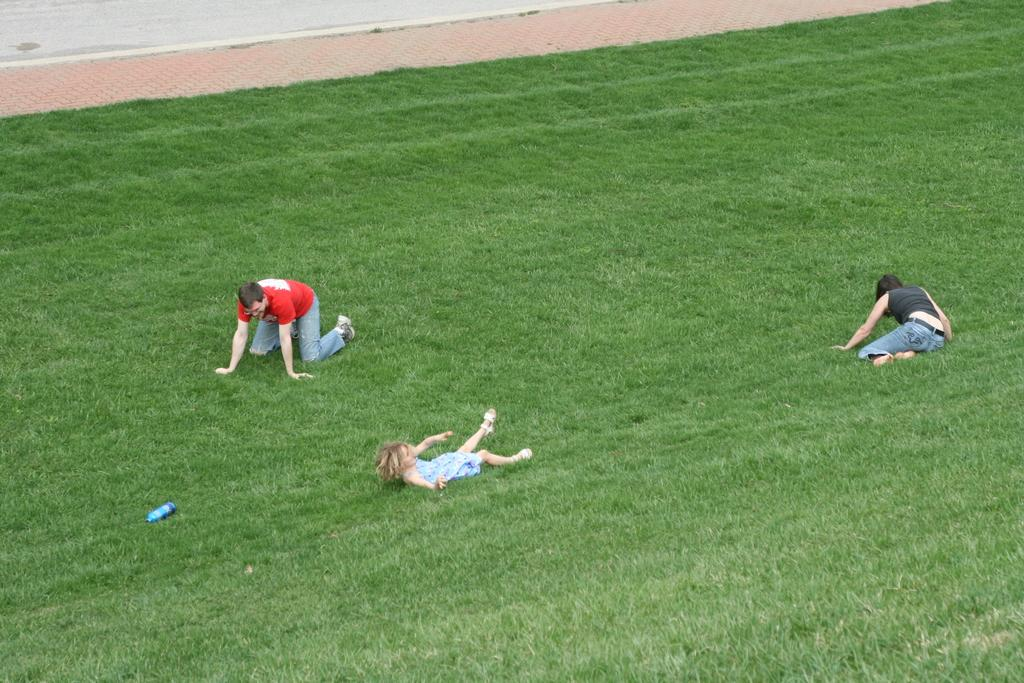Who or what is present in the image? There are people in the image. What object can be seen in the image besides the people? There is a bottle in the image. Where is the bottle located? The bottle is on the grass. What type of historical event is taking place in the image? There is no indication of a historical event in the image; it simply shows people and a bottle on the grass. What kind of pie is being served in the image? There is no pie present in the image. 